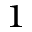<formula> <loc_0><loc_0><loc_500><loc_500>^ { 1 }</formula> 